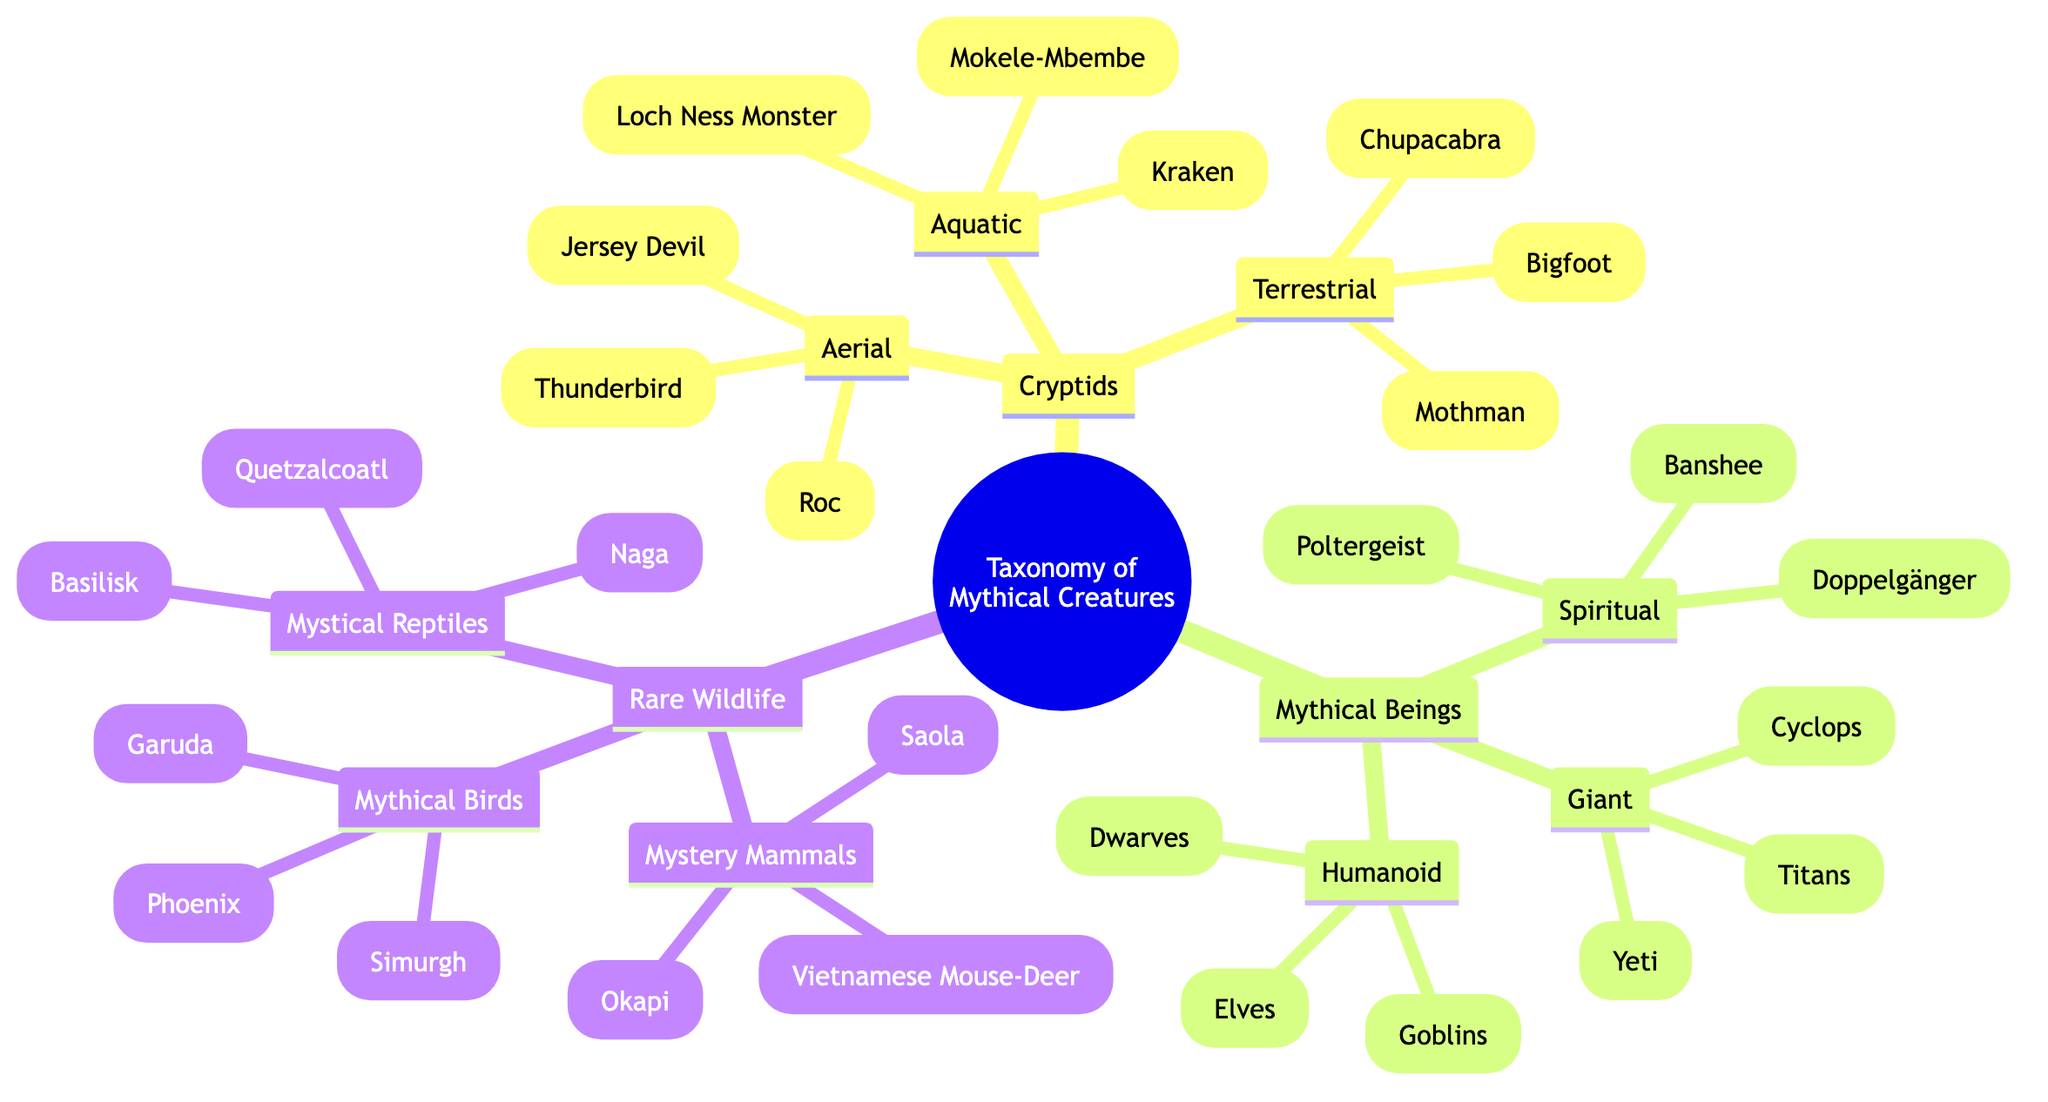What are the examples of terrestrial cryptids? The diagram lists "Bigfoot," "Chupacabra," and "Mothman" as examples of terrestrial cryptids under the Cryptids category.
Answer: Bigfoot, Chupacabra, Mothman How many categories are there under mythical beings? The diagram shows three categories under mythical beings: Humanoid, Spiritual, and Giant. Therefore, the number of categories is three.
Answer: 3 Which aquatic cryptid has a marine habitat? The characteristics for aquatic cryptids note that they all live in a marine habitat, but the Loch Ness Monster is specifically mentioned as one of the examples.
Answer: Loch Ness Monster What is a common characteristic of mythical birds? The "Mythical Birds" category lists characteristics such as having radiant plumage, being associated with rebirth or immortality, and appearing in ancient mythologies. The first mentioned characteristic is radiant plumage.
Answer: Radiant plumage How many examples are provided for giant mythical beings? The category "Giant" under Mythical Beings includes three examples: Cyclops, Titans, and Yeti. Therefore, the total number of examples is three.
Answer: 3 Which subgroup of rare wildlife includes animals like Okapi? The "Mystery Mammals" subgroup is where Okapi, Saola, and Vietnamese Mouse-Deer are mentioned, which means it is the correct subgroup that includes these animals.
Answer: Mystery Mammals What characteristic is unique to spiritual beings? Spiritual beings are characterized by their ethereal or spectral nature and their association with death or the afterlife. This combination of characteristics is unique to them.
Answer: Ethereal nature Which category contains creatures known for their flight capability? The Aerial category under Cryptids contains creatures known for their flight capability, including Roc, Thunderbird, and Jersey Devil.
Answer: Aerial Which mythical being is often associated with magic? The Humanoid category lists Elves, Dwarves, and Goblins, with goblins being particularly noted for their association with various magical abilities.
Answer: Goblins 